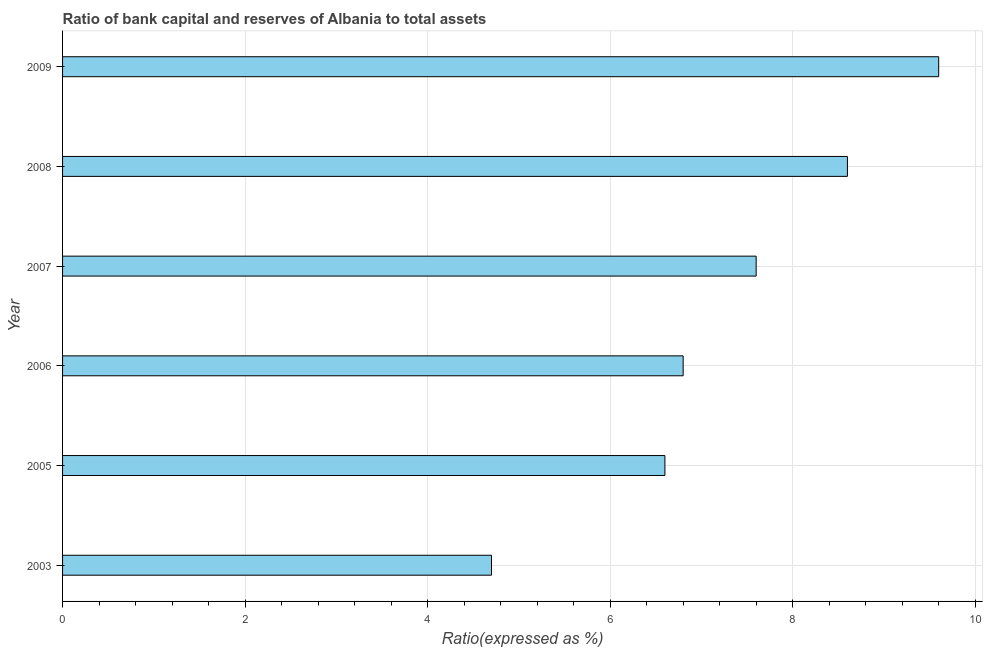Does the graph contain grids?
Offer a terse response. Yes. What is the title of the graph?
Ensure brevity in your answer.  Ratio of bank capital and reserves of Albania to total assets. What is the label or title of the X-axis?
Offer a terse response. Ratio(expressed as %). What is the label or title of the Y-axis?
Offer a very short reply. Year. What is the bank capital to assets ratio in 2008?
Your answer should be very brief. 8.6. Across all years, what is the maximum bank capital to assets ratio?
Make the answer very short. 9.6. Across all years, what is the minimum bank capital to assets ratio?
Your answer should be compact. 4.7. In which year was the bank capital to assets ratio maximum?
Keep it short and to the point. 2009. What is the sum of the bank capital to assets ratio?
Your response must be concise. 43.9. What is the difference between the bank capital to assets ratio in 2006 and 2008?
Ensure brevity in your answer.  -1.8. What is the average bank capital to assets ratio per year?
Provide a succinct answer. 7.32. What is the median bank capital to assets ratio?
Provide a succinct answer. 7.2. Do a majority of the years between 2003 and 2005 (inclusive) have bank capital to assets ratio greater than 6.8 %?
Make the answer very short. No. What is the ratio of the bank capital to assets ratio in 2003 to that in 2009?
Offer a terse response. 0.49. What is the difference between the highest and the lowest bank capital to assets ratio?
Your response must be concise. 4.9. In how many years, is the bank capital to assets ratio greater than the average bank capital to assets ratio taken over all years?
Provide a short and direct response. 3. How many bars are there?
Offer a terse response. 6. Are all the bars in the graph horizontal?
Give a very brief answer. Yes. Are the values on the major ticks of X-axis written in scientific E-notation?
Make the answer very short. No. What is the Ratio(expressed as %) in 2006?
Your answer should be compact. 6.8. What is the Ratio(expressed as %) in 2008?
Your answer should be very brief. 8.6. What is the Ratio(expressed as %) in 2009?
Give a very brief answer. 9.6. What is the difference between the Ratio(expressed as %) in 2003 and 2006?
Offer a terse response. -2.1. What is the difference between the Ratio(expressed as %) in 2003 and 2007?
Offer a terse response. -2.9. What is the difference between the Ratio(expressed as %) in 2003 and 2008?
Your response must be concise. -3.9. What is the difference between the Ratio(expressed as %) in 2003 and 2009?
Offer a terse response. -4.9. What is the difference between the Ratio(expressed as %) in 2005 and 2009?
Ensure brevity in your answer.  -3. What is the difference between the Ratio(expressed as %) in 2006 and 2007?
Keep it short and to the point. -0.8. What is the difference between the Ratio(expressed as %) in 2006 and 2009?
Your answer should be very brief. -2.8. What is the difference between the Ratio(expressed as %) in 2007 and 2009?
Provide a short and direct response. -2. What is the ratio of the Ratio(expressed as %) in 2003 to that in 2005?
Your response must be concise. 0.71. What is the ratio of the Ratio(expressed as %) in 2003 to that in 2006?
Offer a very short reply. 0.69. What is the ratio of the Ratio(expressed as %) in 2003 to that in 2007?
Ensure brevity in your answer.  0.62. What is the ratio of the Ratio(expressed as %) in 2003 to that in 2008?
Your response must be concise. 0.55. What is the ratio of the Ratio(expressed as %) in 2003 to that in 2009?
Give a very brief answer. 0.49. What is the ratio of the Ratio(expressed as %) in 2005 to that in 2007?
Ensure brevity in your answer.  0.87. What is the ratio of the Ratio(expressed as %) in 2005 to that in 2008?
Provide a short and direct response. 0.77. What is the ratio of the Ratio(expressed as %) in 2005 to that in 2009?
Make the answer very short. 0.69. What is the ratio of the Ratio(expressed as %) in 2006 to that in 2007?
Offer a terse response. 0.9. What is the ratio of the Ratio(expressed as %) in 2006 to that in 2008?
Your answer should be compact. 0.79. What is the ratio of the Ratio(expressed as %) in 2006 to that in 2009?
Your response must be concise. 0.71. What is the ratio of the Ratio(expressed as %) in 2007 to that in 2008?
Provide a succinct answer. 0.88. What is the ratio of the Ratio(expressed as %) in 2007 to that in 2009?
Provide a short and direct response. 0.79. What is the ratio of the Ratio(expressed as %) in 2008 to that in 2009?
Your answer should be very brief. 0.9. 